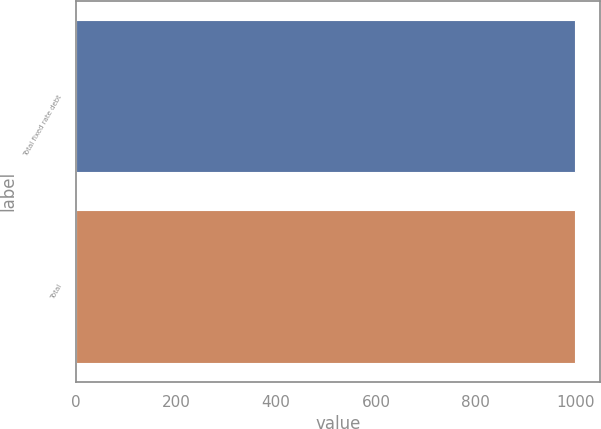<chart> <loc_0><loc_0><loc_500><loc_500><bar_chart><fcel>Total fixed rate debt<fcel>Total<nl><fcel>998<fcel>998.1<nl></chart> 